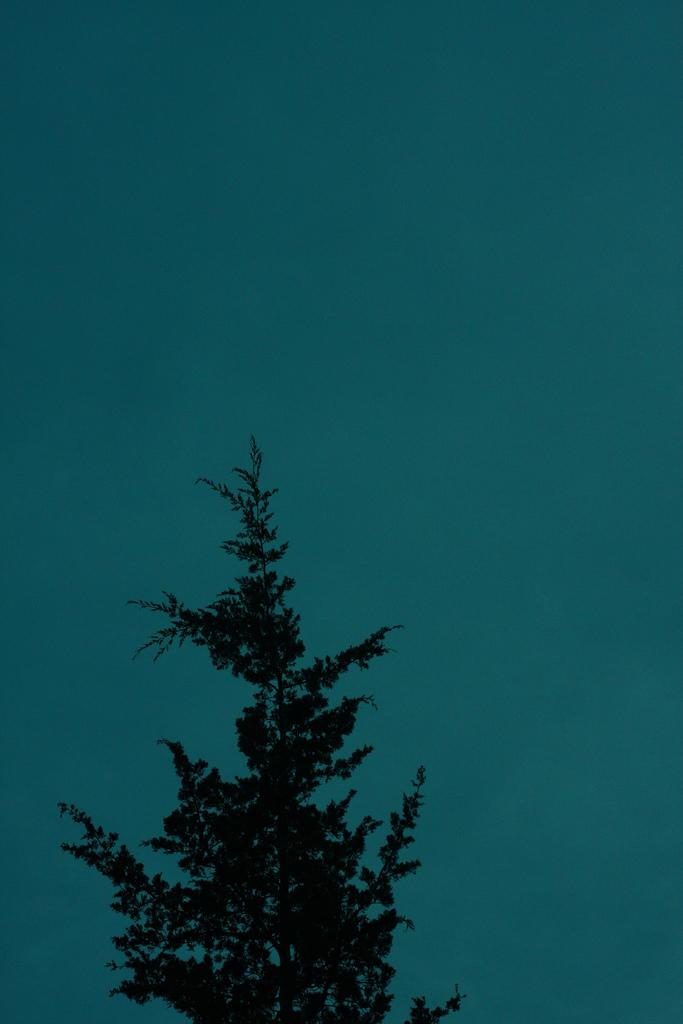What type of plant can be seen in the image? There is a tree in the image. What part of the natural environment is visible in the image? The sky is visible in the image. What appliance can be seen rolling across the grass in the image? There is no appliance rolling across the grass in the image; it only features a tree and the sky. 